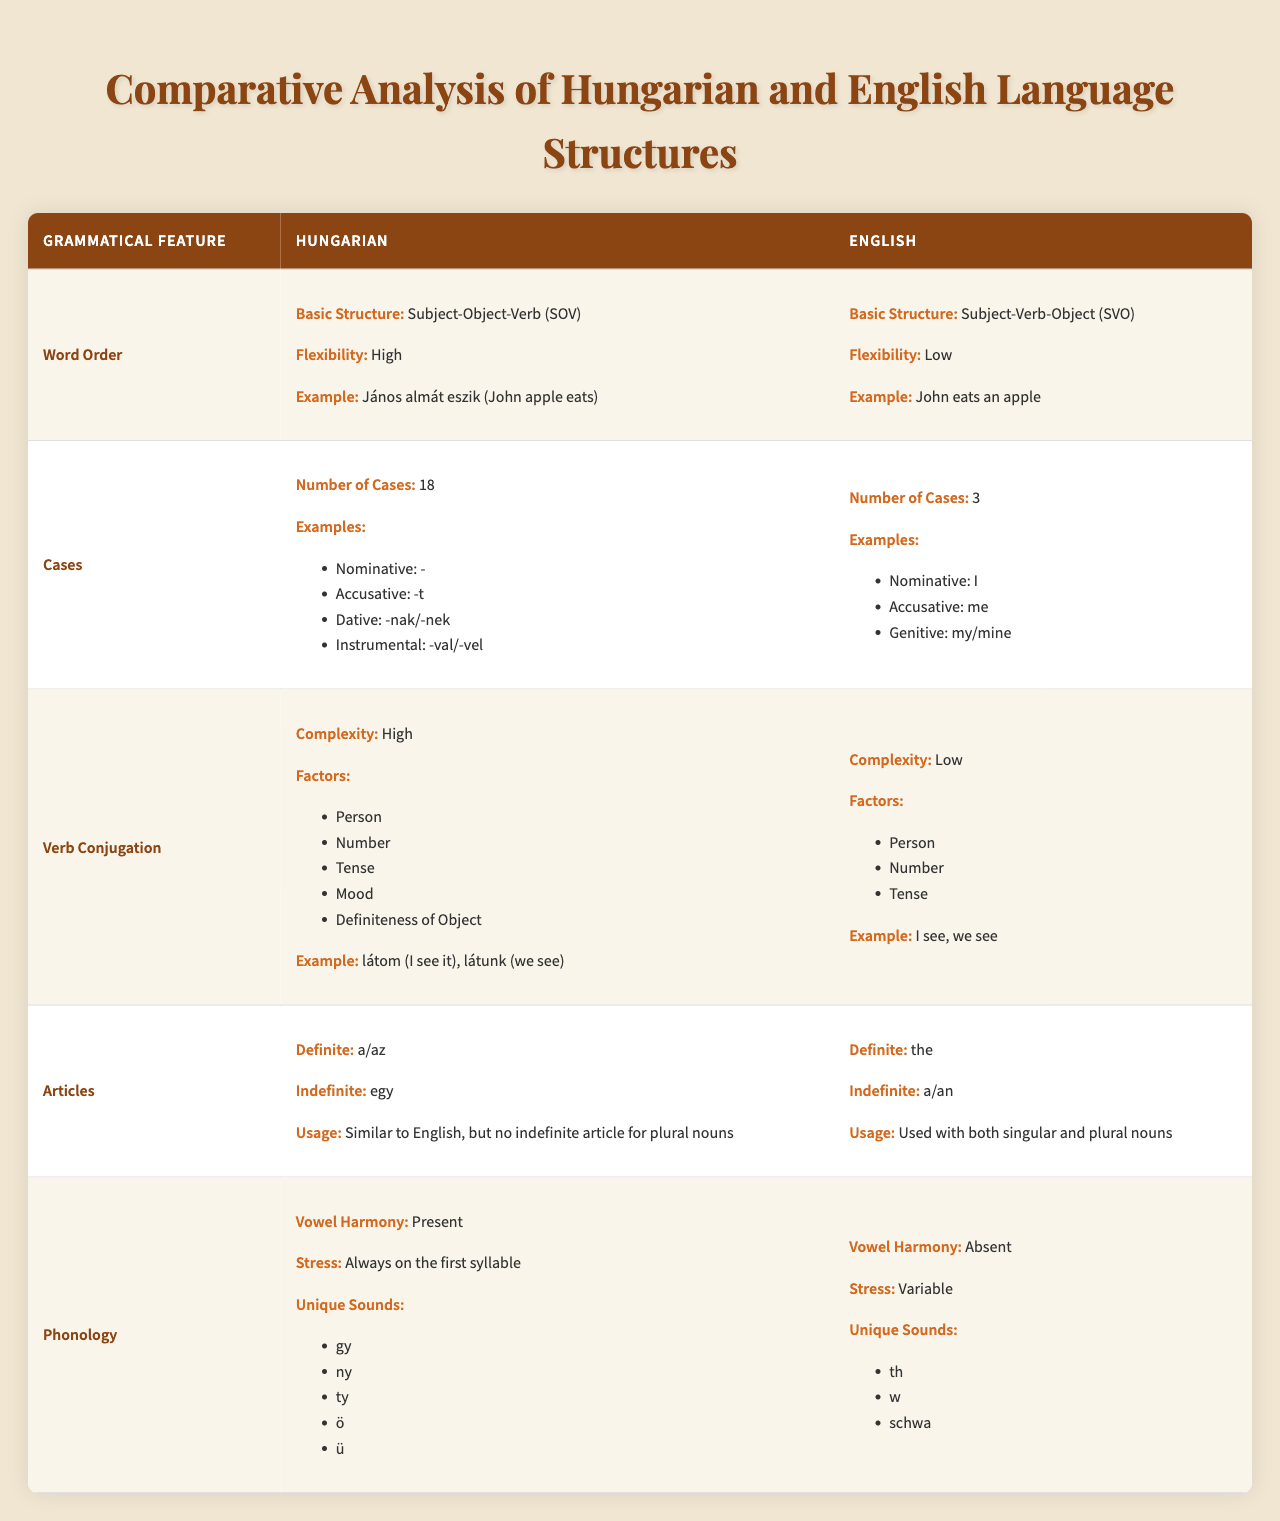What is the basic sentence structure in Hungarian? The table states that the basic structure for Hungarian is Subject-Object-Verb (SOV).
Answer: SOV How many grammatical cases are there in English? According to the table, English has 3 grammatical cases: Nominative, Accusative, and Genitive.
Answer: 3 Does Hungarian use vowel harmony? The table indicates that Hungarian has vowel harmony, which is a unique feature compared to English.
Answer: Yes What is the complexity of verb conjugation in English? The table shows that the complexity of verb conjugation in English is low, with only three factors involved: Person, Number, and Tense.
Answer: Low Which language has a higher number of cases, Hungarian or English? The table shows that Hungarian has 18 cases while English only has 3 cases, making Hungarian higher.
Answer: Hungarian In Hungarian, what are the examples provided for grammatical cases? The table lists four cases in Hungarian: Nominative, Accusative, Dative, and Instrumental, with their respective suffixes.
Answer: Nominative: -, Accusative: -t, Dative: -nak/-nek, Instrumental: -val/-vel What do both languages use to denote definiteness in articles? According to the table, both languages have definite articles, but they differ in formed usage. Hungarian uses "a/az," while English uses "the."
Answer: Yes What is the example given for verb conjugation in Hungarian? The table provides two examples of Hungarian verb conjugation: "látom (I see it)" and "látunk (we see)."
Answer: látom and látunk Which language has a more flexible word order according to the table? The table states that Hungarian has a high flexibility in word order compared to the low flexibility of English.
Answer: Hungarian What are the unique sounds present in English that are not in Hungarian? The table lists "th," "w," and "schwa" as unique sounds present in English, while Hungarian has its own unique sounds.
Answer: th, w, schwa How many grammatical features are compared in the table? There are five grammatical features analyzed in the table: Word Order, Cases, Verb Conjugation, Articles, and Phonology.
Answer: 5 Are there more unique sounds in Hungarian than in English? According to the table, Hungarian has more unique sounds (gy, ny, ty, ö, ü) compared to those listed for English (th, w, schwa).
Answer: Yes What is the primary difference in the usage of articles between the two languages? The table notes that Hungarian does not have an indefinite article for plural nouns, unlike English, which uses articles for plural nouns.
Answer: No indefinite article for plural nouns in Hungarian 